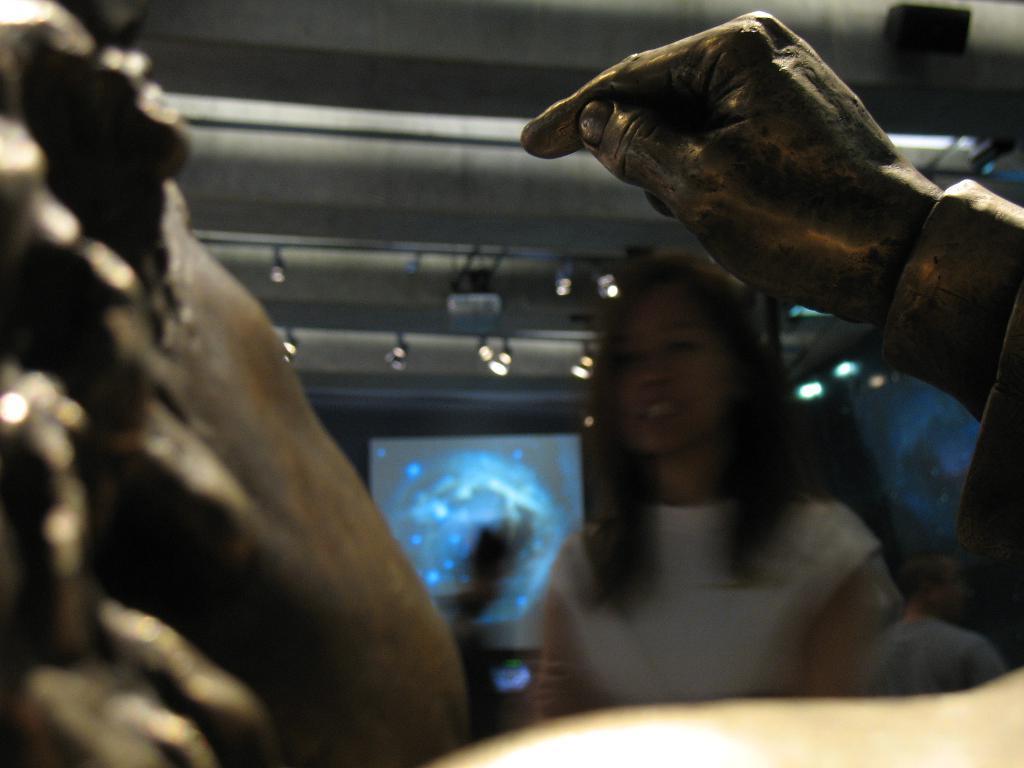Could you give a brief overview of what you see in this image? In this image we can see the depiction of a person's hand. We can also see a woman wearing the white top. In the background we can see the display screen and also the lights. 